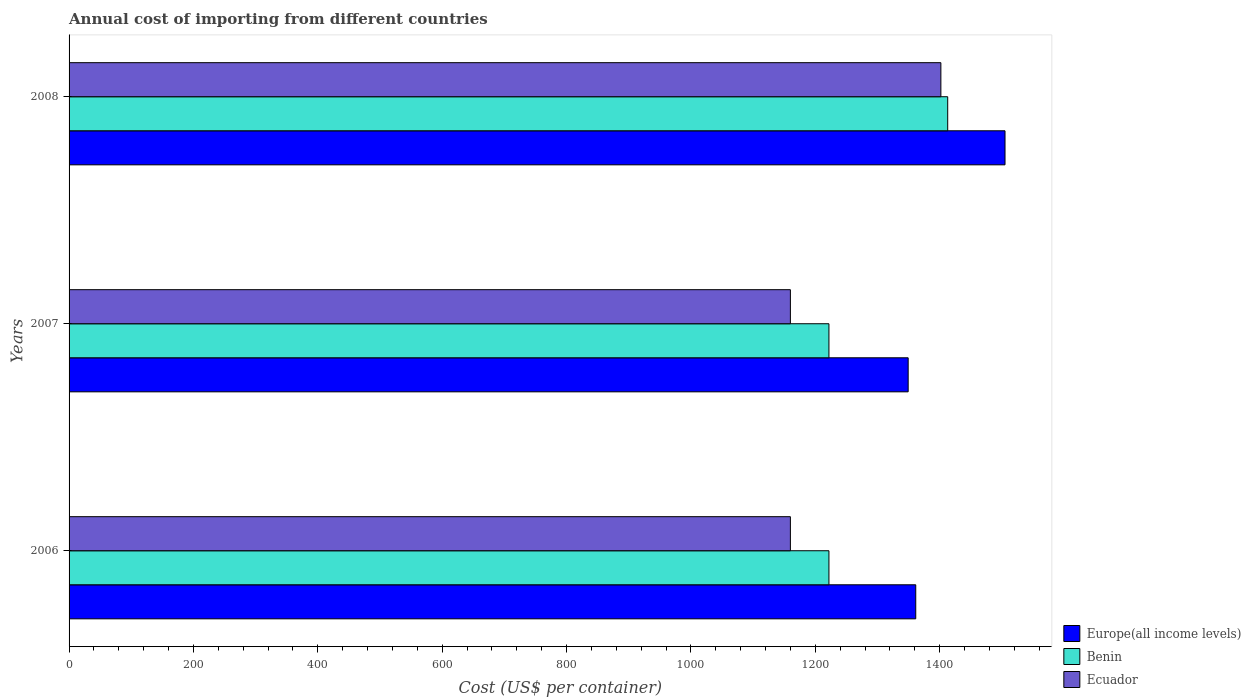How many different coloured bars are there?
Your answer should be very brief. 3. How many groups of bars are there?
Your answer should be compact. 3. How many bars are there on the 1st tick from the top?
Keep it short and to the point. 3. What is the label of the 2nd group of bars from the top?
Keep it short and to the point. 2007. What is the total annual cost of importing in Ecuador in 2007?
Keep it short and to the point. 1160. Across all years, what is the maximum total annual cost of importing in Ecuador?
Provide a succinct answer. 1402. Across all years, what is the minimum total annual cost of importing in Ecuador?
Ensure brevity in your answer.  1160. What is the total total annual cost of importing in Benin in the graph?
Make the answer very short. 3857. What is the difference between the total annual cost of importing in Ecuador in 2007 and that in 2008?
Give a very brief answer. -242. What is the difference between the total annual cost of importing in Benin in 2008 and the total annual cost of importing in Europe(all income levels) in 2007?
Your answer should be compact. 63.59. What is the average total annual cost of importing in Europe(all income levels) per year?
Your answer should be very brief. 1405.4. In the year 2007, what is the difference between the total annual cost of importing in Europe(all income levels) and total annual cost of importing in Ecuador?
Make the answer very short. 189.41. In how many years, is the total annual cost of importing in Europe(all income levels) greater than 1240 US$?
Ensure brevity in your answer.  3. What is the ratio of the total annual cost of importing in Europe(all income levels) in 2007 to that in 2008?
Your answer should be compact. 0.9. Is the total annual cost of importing in Ecuador in 2006 less than that in 2007?
Give a very brief answer. No. Is the difference between the total annual cost of importing in Europe(all income levels) in 2006 and 2008 greater than the difference between the total annual cost of importing in Ecuador in 2006 and 2008?
Offer a very short reply. Yes. What is the difference between the highest and the second highest total annual cost of importing in Europe(all income levels)?
Offer a terse response. 143.56. What is the difference between the highest and the lowest total annual cost of importing in Europe(all income levels)?
Your answer should be compact. 155.76. In how many years, is the total annual cost of importing in Benin greater than the average total annual cost of importing in Benin taken over all years?
Offer a terse response. 1. What does the 1st bar from the top in 2008 represents?
Ensure brevity in your answer.  Ecuador. What does the 3rd bar from the bottom in 2007 represents?
Ensure brevity in your answer.  Ecuador. Is it the case that in every year, the sum of the total annual cost of importing in Ecuador and total annual cost of importing in Benin is greater than the total annual cost of importing in Europe(all income levels)?
Offer a very short reply. Yes. How many bars are there?
Provide a succinct answer. 9. Are all the bars in the graph horizontal?
Give a very brief answer. Yes. Are the values on the major ticks of X-axis written in scientific E-notation?
Keep it short and to the point. No. How are the legend labels stacked?
Give a very brief answer. Vertical. What is the title of the graph?
Give a very brief answer. Annual cost of importing from different countries. What is the label or title of the X-axis?
Your answer should be compact. Cost (US$ per container). What is the Cost (US$ per container) in Europe(all income levels) in 2006?
Keep it short and to the point. 1361.61. What is the Cost (US$ per container) in Benin in 2006?
Offer a very short reply. 1222. What is the Cost (US$ per container) of Ecuador in 2006?
Ensure brevity in your answer.  1160. What is the Cost (US$ per container) of Europe(all income levels) in 2007?
Your answer should be very brief. 1349.41. What is the Cost (US$ per container) in Benin in 2007?
Your answer should be very brief. 1222. What is the Cost (US$ per container) in Ecuador in 2007?
Make the answer very short. 1160. What is the Cost (US$ per container) in Europe(all income levels) in 2008?
Ensure brevity in your answer.  1505.17. What is the Cost (US$ per container) in Benin in 2008?
Provide a short and direct response. 1413. What is the Cost (US$ per container) of Ecuador in 2008?
Offer a terse response. 1402. Across all years, what is the maximum Cost (US$ per container) in Europe(all income levels)?
Your answer should be compact. 1505.17. Across all years, what is the maximum Cost (US$ per container) in Benin?
Offer a very short reply. 1413. Across all years, what is the maximum Cost (US$ per container) of Ecuador?
Give a very brief answer. 1402. Across all years, what is the minimum Cost (US$ per container) in Europe(all income levels)?
Your answer should be very brief. 1349.41. Across all years, what is the minimum Cost (US$ per container) of Benin?
Provide a succinct answer. 1222. Across all years, what is the minimum Cost (US$ per container) in Ecuador?
Your response must be concise. 1160. What is the total Cost (US$ per container) of Europe(all income levels) in the graph?
Your response must be concise. 4216.19. What is the total Cost (US$ per container) in Benin in the graph?
Offer a very short reply. 3857. What is the total Cost (US$ per container) of Ecuador in the graph?
Your answer should be compact. 3722. What is the difference between the Cost (US$ per container) of Europe(all income levels) in 2006 and that in 2007?
Provide a short and direct response. 12.2. What is the difference between the Cost (US$ per container) in Ecuador in 2006 and that in 2007?
Give a very brief answer. 0. What is the difference between the Cost (US$ per container) of Europe(all income levels) in 2006 and that in 2008?
Your response must be concise. -143.56. What is the difference between the Cost (US$ per container) in Benin in 2006 and that in 2008?
Ensure brevity in your answer.  -191. What is the difference between the Cost (US$ per container) of Ecuador in 2006 and that in 2008?
Offer a terse response. -242. What is the difference between the Cost (US$ per container) in Europe(all income levels) in 2007 and that in 2008?
Provide a succinct answer. -155.76. What is the difference between the Cost (US$ per container) in Benin in 2007 and that in 2008?
Ensure brevity in your answer.  -191. What is the difference between the Cost (US$ per container) in Ecuador in 2007 and that in 2008?
Make the answer very short. -242. What is the difference between the Cost (US$ per container) in Europe(all income levels) in 2006 and the Cost (US$ per container) in Benin in 2007?
Keep it short and to the point. 139.61. What is the difference between the Cost (US$ per container) in Europe(all income levels) in 2006 and the Cost (US$ per container) in Ecuador in 2007?
Make the answer very short. 201.61. What is the difference between the Cost (US$ per container) in Europe(all income levels) in 2006 and the Cost (US$ per container) in Benin in 2008?
Offer a terse response. -51.39. What is the difference between the Cost (US$ per container) of Europe(all income levels) in 2006 and the Cost (US$ per container) of Ecuador in 2008?
Offer a terse response. -40.39. What is the difference between the Cost (US$ per container) in Benin in 2006 and the Cost (US$ per container) in Ecuador in 2008?
Your answer should be compact. -180. What is the difference between the Cost (US$ per container) of Europe(all income levels) in 2007 and the Cost (US$ per container) of Benin in 2008?
Make the answer very short. -63.59. What is the difference between the Cost (US$ per container) of Europe(all income levels) in 2007 and the Cost (US$ per container) of Ecuador in 2008?
Offer a terse response. -52.59. What is the difference between the Cost (US$ per container) in Benin in 2007 and the Cost (US$ per container) in Ecuador in 2008?
Your answer should be compact. -180. What is the average Cost (US$ per container) of Europe(all income levels) per year?
Give a very brief answer. 1405.4. What is the average Cost (US$ per container) in Benin per year?
Your answer should be very brief. 1285.67. What is the average Cost (US$ per container) in Ecuador per year?
Provide a short and direct response. 1240.67. In the year 2006, what is the difference between the Cost (US$ per container) in Europe(all income levels) and Cost (US$ per container) in Benin?
Offer a very short reply. 139.61. In the year 2006, what is the difference between the Cost (US$ per container) of Europe(all income levels) and Cost (US$ per container) of Ecuador?
Your answer should be compact. 201.61. In the year 2006, what is the difference between the Cost (US$ per container) of Benin and Cost (US$ per container) of Ecuador?
Your answer should be compact. 62. In the year 2007, what is the difference between the Cost (US$ per container) in Europe(all income levels) and Cost (US$ per container) in Benin?
Your answer should be compact. 127.41. In the year 2007, what is the difference between the Cost (US$ per container) of Europe(all income levels) and Cost (US$ per container) of Ecuador?
Make the answer very short. 189.41. In the year 2008, what is the difference between the Cost (US$ per container) in Europe(all income levels) and Cost (US$ per container) in Benin?
Offer a very short reply. 92.17. In the year 2008, what is the difference between the Cost (US$ per container) in Europe(all income levels) and Cost (US$ per container) in Ecuador?
Your answer should be very brief. 103.17. What is the ratio of the Cost (US$ per container) of Europe(all income levels) in 2006 to that in 2007?
Provide a succinct answer. 1.01. What is the ratio of the Cost (US$ per container) in Europe(all income levels) in 2006 to that in 2008?
Your answer should be compact. 0.9. What is the ratio of the Cost (US$ per container) in Benin in 2006 to that in 2008?
Ensure brevity in your answer.  0.86. What is the ratio of the Cost (US$ per container) of Ecuador in 2006 to that in 2008?
Ensure brevity in your answer.  0.83. What is the ratio of the Cost (US$ per container) of Europe(all income levels) in 2007 to that in 2008?
Offer a terse response. 0.9. What is the ratio of the Cost (US$ per container) of Benin in 2007 to that in 2008?
Your answer should be compact. 0.86. What is the ratio of the Cost (US$ per container) in Ecuador in 2007 to that in 2008?
Your answer should be very brief. 0.83. What is the difference between the highest and the second highest Cost (US$ per container) of Europe(all income levels)?
Provide a short and direct response. 143.56. What is the difference between the highest and the second highest Cost (US$ per container) of Benin?
Ensure brevity in your answer.  191. What is the difference between the highest and the second highest Cost (US$ per container) of Ecuador?
Provide a succinct answer. 242. What is the difference between the highest and the lowest Cost (US$ per container) of Europe(all income levels)?
Offer a terse response. 155.76. What is the difference between the highest and the lowest Cost (US$ per container) in Benin?
Provide a short and direct response. 191. What is the difference between the highest and the lowest Cost (US$ per container) of Ecuador?
Provide a succinct answer. 242. 